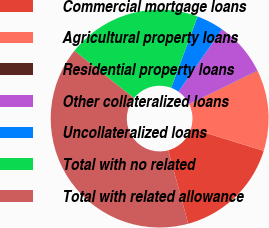<chart> <loc_0><loc_0><loc_500><loc_500><pie_chart><fcel>Commercial mortgage loans<fcel>Agricultural property loans<fcel>Residential property loans<fcel>Other collateralized loans<fcel>Uncollateralized loans<fcel>Total with no related<fcel>Total with related allowance<nl><fcel>15.99%<fcel>12.01%<fcel>0.05%<fcel>8.02%<fcel>4.04%<fcel>19.98%<fcel>39.9%<nl></chart> 